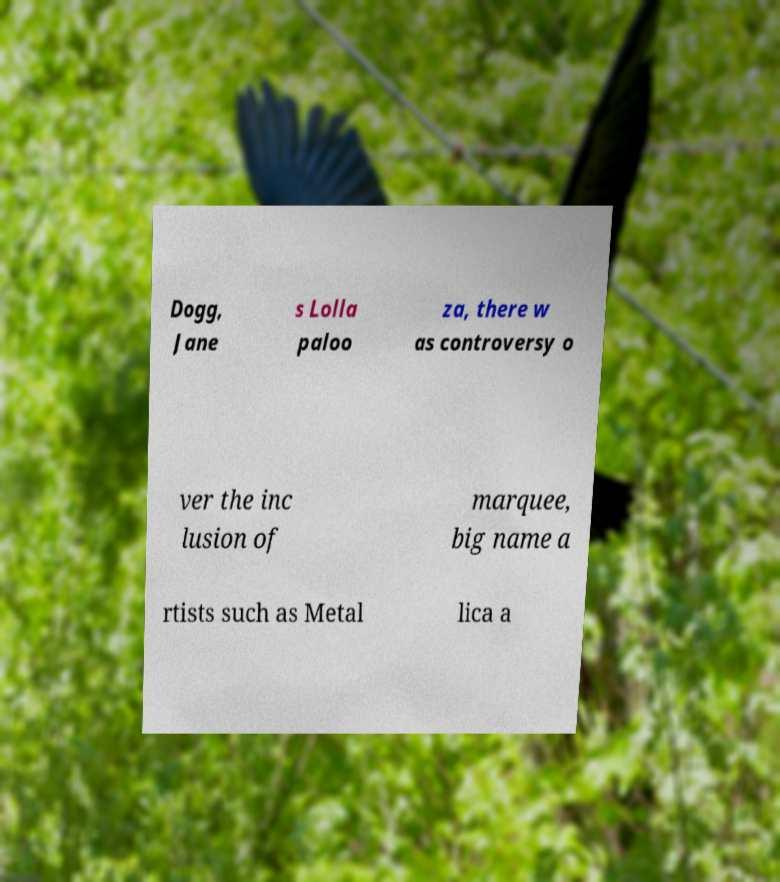What messages or text are displayed in this image? I need them in a readable, typed format. Dogg, Jane s Lolla paloo za, there w as controversy o ver the inc lusion of marquee, big name a rtists such as Metal lica a 